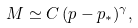Convert formula to latex. <formula><loc_0><loc_0><loc_500><loc_500>M \simeq C \, ( p - p _ { * } ) ^ { \gamma } ,</formula> 